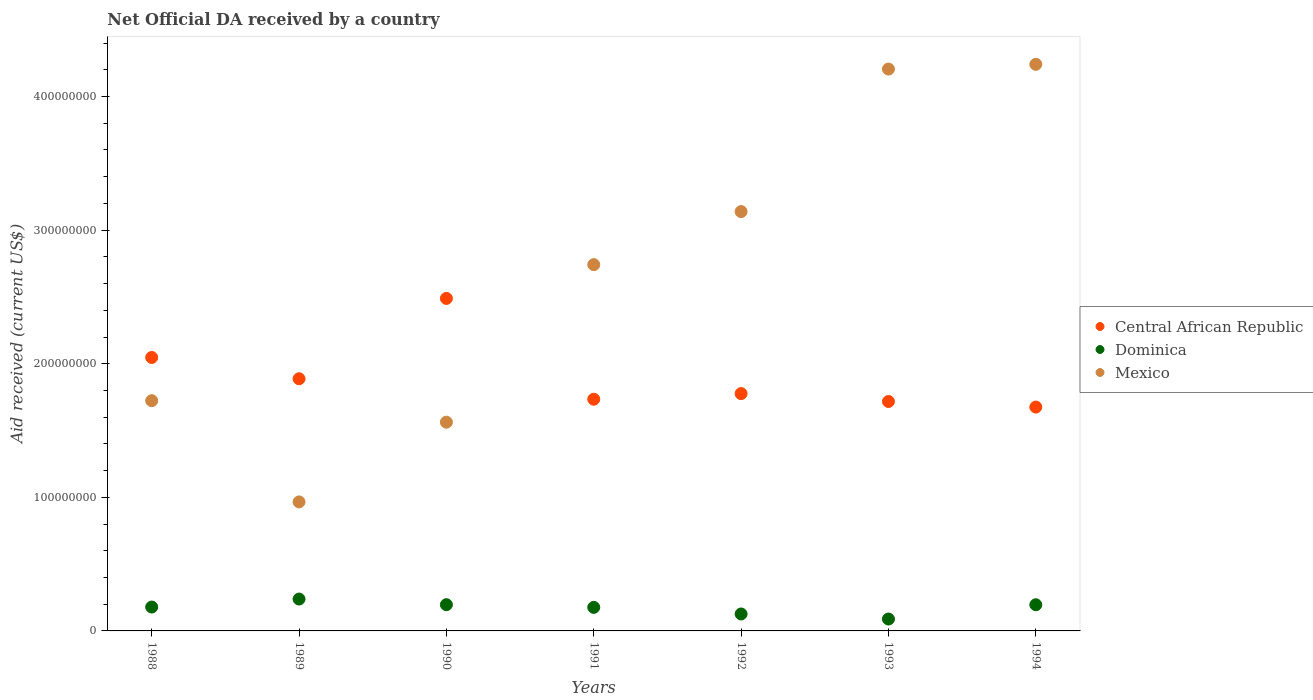What is the net official development assistance aid received in Mexico in 1988?
Ensure brevity in your answer.  1.72e+08. Across all years, what is the maximum net official development assistance aid received in Central African Republic?
Offer a very short reply. 2.49e+08. Across all years, what is the minimum net official development assistance aid received in Dominica?
Keep it short and to the point. 8.91e+06. In which year was the net official development assistance aid received in Mexico minimum?
Your response must be concise. 1989. What is the total net official development assistance aid received in Mexico in the graph?
Offer a terse response. 1.86e+09. What is the difference between the net official development assistance aid received in Central African Republic in 1990 and that in 1991?
Give a very brief answer. 7.54e+07. What is the difference between the net official development assistance aid received in Central African Republic in 1994 and the net official development assistance aid received in Dominica in 1992?
Provide a succinct answer. 1.55e+08. What is the average net official development assistance aid received in Dominica per year?
Give a very brief answer. 1.72e+07. In the year 1993, what is the difference between the net official development assistance aid received in Central African Republic and net official development assistance aid received in Dominica?
Your answer should be compact. 1.63e+08. What is the ratio of the net official development assistance aid received in Central African Republic in 1993 to that in 1994?
Offer a terse response. 1.02. Is the net official development assistance aid received in Central African Republic in 1988 less than that in 1993?
Keep it short and to the point. No. What is the difference between the highest and the second highest net official development assistance aid received in Mexico?
Your response must be concise. 3.56e+06. What is the difference between the highest and the lowest net official development assistance aid received in Mexico?
Offer a terse response. 3.28e+08. In how many years, is the net official development assistance aid received in Central African Republic greater than the average net official development assistance aid received in Central African Republic taken over all years?
Offer a terse response. 2. Is the sum of the net official development assistance aid received in Mexico in 1988 and 1991 greater than the maximum net official development assistance aid received in Central African Republic across all years?
Provide a short and direct response. Yes. Is it the case that in every year, the sum of the net official development assistance aid received in Dominica and net official development assistance aid received in Mexico  is greater than the net official development assistance aid received in Central African Republic?
Your answer should be compact. No. Does the net official development assistance aid received in Dominica monotonically increase over the years?
Your answer should be very brief. No. Is the net official development assistance aid received in Dominica strictly greater than the net official development assistance aid received in Central African Republic over the years?
Keep it short and to the point. No. Is the net official development assistance aid received in Central African Republic strictly less than the net official development assistance aid received in Mexico over the years?
Offer a very short reply. No. How many dotlines are there?
Ensure brevity in your answer.  3. How many years are there in the graph?
Your answer should be very brief. 7. Does the graph contain any zero values?
Offer a very short reply. No. Does the graph contain grids?
Ensure brevity in your answer.  No. Where does the legend appear in the graph?
Provide a short and direct response. Center right. What is the title of the graph?
Offer a terse response. Net Official DA received by a country. What is the label or title of the X-axis?
Offer a very short reply. Years. What is the label or title of the Y-axis?
Provide a short and direct response. Aid received (current US$). What is the Aid received (current US$) of Central African Republic in 1988?
Provide a short and direct response. 2.05e+08. What is the Aid received (current US$) of Dominica in 1988?
Make the answer very short. 1.79e+07. What is the Aid received (current US$) of Mexico in 1988?
Provide a succinct answer. 1.72e+08. What is the Aid received (current US$) in Central African Republic in 1989?
Ensure brevity in your answer.  1.89e+08. What is the Aid received (current US$) of Dominica in 1989?
Ensure brevity in your answer.  2.39e+07. What is the Aid received (current US$) in Mexico in 1989?
Make the answer very short. 9.66e+07. What is the Aid received (current US$) of Central African Republic in 1990?
Provide a short and direct response. 2.49e+08. What is the Aid received (current US$) in Dominica in 1990?
Offer a terse response. 1.96e+07. What is the Aid received (current US$) of Mexico in 1990?
Your answer should be very brief. 1.56e+08. What is the Aid received (current US$) of Central African Republic in 1991?
Your response must be concise. 1.73e+08. What is the Aid received (current US$) in Dominica in 1991?
Provide a short and direct response. 1.76e+07. What is the Aid received (current US$) of Mexico in 1991?
Your response must be concise. 2.74e+08. What is the Aid received (current US$) in Central African Republic in 1992?
Provide a short and direct response. 1.78e+08. What is the Aid received (current US$) in Dominica in 1992?
Offer a terse response. 1.27e+07. What is the Aid received (current US$) of Mexico in 1992?
Ensure brevity in your answer.  3.14e+08. What is the Aid received (current US$) in Central African Republic in 1993?
Your answer should be very brief. 1.72e+08. What is the Aid received (current US$) in Dominica in 1993?
Ensure brevity in your answer.  8.91e+06. What is the Aid received (current US$) in Mexico in 1993?
Provide a short and direct response. 4.21e+08. What is the Aid received (current US$) in Central African Republic in 1994?
Your response must be concise. 1.68e+08. What is the Aid received (current US$) in Dominica in 1994?
Keep it short and to the point. 1.96e+07. What is the Aid received (current US$) of Mexico in 1994?
Make the answer very short. 4.24e+08. Across all years, what is the maximum Aid received (current US$) of Central African Republic?
Make the answer very short. 2.49e+08. Across all years, what is the maximum Aid received (current US$) of Dominica?
Give a very brief answer. 2.39e+07. Across all years, what is the maximum Aid received (current US$) in Mexico?
Offer a very short reply. 4.24e+08. Across all years, what is the minimum Aid received (current US$) in Central African Republic?
Make the answer very short. 1.68e+08. Across all years, what is the minimum Aid received (current US$) in Dominica?
Give a very brief answer. 8.91e+06. Across all years, what is the minimum Aid received (current US$) in Mexico?
Ensure brevity in your answer.  9.66e+07. What is the total Aid received (current US$) of Central African Republic in the graph?
Keep it short and to the point. 1.33e+09. What is the total Aid received (current US$) in Dominica in the graph?
Give a very brief answer. 1.20e+08. What is the total Aid received (current US$) of Mexico in the graph?
Provide a succinct answer. 1.86e+09. What is the difference between the Aid received (current US$) in Central African Republic in 1988 and that in 1989?
Offer a very short reply. 1.59e+07. What is the difference between the Aid received (current US$) in Dominica in 1988 and that in 1989?
Make the answer very short. -5.98e+06. What is the difference between the Aid received (current US$) in Mexico in 1988 and that in 1989?
Your response must be concise. 7.58e+07. What is the difference between the Aid received (current US$) of Central African Republic in 1988 and that in 1990?
Your answer should be compact. -4.42e+07. What is the difference between the Aid received (current US$) of Dominica in 1988 and that in 1990?
Make the answer very short. -1.76e+06. What is the difference between the Aid received (current US$) in Mexico in 1988 and that in 1990?
Keep it short and to the point. 1.61e+07. What is the difference between the Aid received (current US$) of Central African Republic in 1988 and that in 1991?
Ensure brevity in your answer.  3.12e+07. What is the difference between the Aid received (current US$) of Mexico in 1988 and that in 1991?
Offer a terse response. -1.02e+08. What is the difference between the Aid received (current US$) in Central African Republic in 1988 and that in 1992?
Offer a terse response. 2.70e+07. What is the difference between the Aid received (current US$) in Dominica in 1988 and that in 1992?
Provide a succinct answer. 5.18e+06. What is the difference between the Aid received (current US$) in Mexico in 1988 and that in 1992?
Make the answer very short. -1.42e+08. What is the difference between the Aid received (current US$) of Central African Republic in 1988 and that in 1993?
Make the answer very short. 3.30e+07. What is the difference between the Aid received (current US$) of Dominica in 1988 and that in 1993?
Provide a short and direct response. 8.97e+06. What is the difference between the Aid received (current US$) in Mexico in 1988 and that in 1993?
Provide a short and direct response. -2.48e+08. What is the difference between the Aid received (current US$) of Central African Republic in 1988 and that in 1994?
Offer a very short reply. 3.71e+07. What is the difference between the Aid received (current US$) in Dominica in 1988 and that in 1994?
Your response must be concise. -1.71e+06. What is the difference between the Aid received (current US$) in Mexico in 1988 and that in 1994?
Provide a succinct answer. -2.52e+08. What is the difference between the Aid received (current US$) in Central African Republic in 1989 and that in 1990?
Offer a very short reply. -6.01e+07. What is the difference between the Aid received (current US$) in Dominica in 1989 and that in 1990?
Provide a succinct answer. 4.22e+06. What is the difference between the Aid received (current US$) of Mexico in 1989 and that in 1990?
Give a very brief answer. -5.97e+07. What is the difference between the Aid received (current US$) in Central African Republic in 1989 and that in 1991?
Offer a terse response. 1.53e+07. What is the difference between the Aid received (current US$) in Dominica in 1989 and that in 1991?
Your answer should be very brief. 6.23e+06. What is the difference between the Aid received (current US$) of Mexico in 1989 and that in 1991?
Keep it short and to the point. -1.78e+08. What is the difference between the Aid received (current US$) of Central African Republic in 1989 and that in 1992?
Offer a very short reply. 1.11e+07. What is the difference between the Aid received (current US$) of Dominica in 1989 and that in 1992?
Your answer should be very brief. 1.12e+07. What is the difference between the Aid received (current US$) of Mexico in 1989 and that in 1992?
Provide a succinct answer. -2.17e+08. What is the difference between the Aid received (current US$) in Central African Republic in 1989 and that in 1993?
Provide a succinct answer. 1.70e+07. What is the difference between the Aid received (current US$) of Dominica in 1989 and that in 1993?
Offer a very short reply. 1.50e+07. What is the difference between the Aid received (current US$) in Mexico in 1989 and that in 1993?
Your response must be concise. -3.24e+08. What is the difference between the Aid received (current US$) in Central African Republic in 1989 and that in 1994?
Give a very brief answer. 2.12e+07. What is the difference between the Aid received (current US$) in Dominica in 1989 and that in 1994?
Your answer should be compact. 4.27e+06. What is the difference between the Aid received (current US$) of Mexico in 1989 and that in 1994?
Your answer should be compact. -3.28e+08. What is the difference between the Aid received (current US$) of Central African Republic in 1990 and that in 1991?
Offer a very short reply. 7.54e+07. What is the difference between the Aid received (current US$) in Dominica in 1990 and that in 1991?
Offer a terse response. 2.01e+06. What is the difference between the Aid received (current US$) of Mexico in 1990 and that in 1991?
Give a very brief answer. -1.18e+08. What is the difference between the Aid received (current US$) of Central African Republic in 1990 and that in 1992?
Keep it short and to the point. 7.12e+07. What is the difference between the Aid received (current US$) in Dominica in 1990 and that in 1992?
Your answer should be very brief. 6.94e+06. What is the difference between the Aid received (current US$) of Mexico in 1990 and that in 1992?
Make the answer very short. -1.58e+08. What is the difference between the Aid received (current US$) of Central African Republic in 1990 and that in 1993?
Make the answer very short. 7.72e+07. What is the difference between the Aid received (current US$) in Dominica in 1990 and that in 1993?
Ensure brevity in your answer.  1.07e+07. What is the difference between the Aid received (current US$) in Mexico in 1990 and that in 1993?
Your answer should be compact. -2.64e+08. What is the difference between the Aid received (current US$) in Central African Republic in 1990 and that in 1994?
Make the answer very short. 8.13e+07. What is the difference between the Aid received (current US$) in Mexico in 1990 and that in 1994?
Your answer should be very brief. -2.68e+08. What is the difference between the Aid received (current US$) in Central African Republic in 1991 and that in 1992?
Provide a succinct answer. -4.21e+06. What is the difference between the Aid received (current US$) of Dominica in 1991 and that in 1992?
Provide a short and direct response. 4.93e+06. What is the difference between the Aid received (current US$) in Mexico in 1991 and that in 1992?
Your answer should be very brief. -3.97e+07. What is the difference between the Aid received (current US$) in Central African Republic in 1991 and that in 1993?
Your response must be concise. 1.70e+06. What is the difference between the Aid received (current US$) of Dominica in 1991 and that in 1993?
Your response must be concise. 8.72e+06. What is the difference between the Aid received (current US$) of Mexico in 1991 and that in 1993?
Provide a succinct answer. -1.46e+08. What is the difference between the Aid received (current US$) in Central African Republic in 1991 and that in 1994?
Provide a succinct answer. 5.88e+06. What is the difference between the Aid received (current US$) in Dominica in 1991 and that in 1994?
Keep it short and to the point. -1.96e+06. What is the difference between the Aid received (current US$) of Mexico in 1991 and that in 1994?
Give a very brief answer. -1.50e+08. What is the difference between the Aid received (current US$) in Central African Republic in 1992 and that in 1993?
Ensure brevity in your answer.  5.91e+06. What is the difference between the Aid received (current US$) in Dominica in 1992 and that in 1993?
Offer a terse response. 3.79e+06. What is the difference between the Aid received (current US$) in Mexico in 1992 and that in 1993?
Keep it short and to the point. -1.07e+08. What is the difference between the Aid received (current US$) of Central African Republic in 1992 and that in 1994?
Provide a succinct answer. 1.01e+07. What is the difference between the Aid received (current US$) of Dominica in 1992 and that in 1994?
Your answer should be very brief. -6.89e+06. What is the difference between the Aid received (current US$) of Mexico in 1992 and that in 1994?
Your response must be concise. -1.10e+08. What is the difference between the Aid received (current US$) in Central African Republic in 1993 and that in 1994?
Give a very brief answer. 4.18e+06. What is the difference between the Aid received (current US$) of Dominica in 1993 and that in 1994?
Keep it short and to the point. -1.07e+07. What is the difference between the Aid received (current US$) in Mexico in 1993 and that in 1994?
Your answer should be very brief. -3.56e+06. What is the difference between the Aid received (current US$) in Central African Republic in 1988 and the Aid received (current US$) in Dominica in 1989?
Your answer should be very brief. 1.81e+08. What is the difference between the Aid received (current US$) of Central African Republic in 1988 and the Aid received (current US$) of Mexico in 1989?
Offer a terse response. 1.08e+08. What is the difference between the Aid received (current US$) in Dominica in 1988 and the Aid received (current US$) in Mexico in 1989?
Offer a very short reply. -7.87e+07. What is the difference between the Aid received (current US$) in Central African Republic in 1988 and the Aid received (current US$) in Dominica in 1990?
Keep it short and to the point. 1.85e+08. What is the difference between the Aid received (current US$) of Central African Republic in 1988 and the Aid received (current US$) of Mexico in 1990?
Keep it short and to the point. 4.84e+07. What is the difference between the Aid received (current US$) in Dominica in 1988 and the Aid received (current US$) in Mexico in 1990?
Keep it short and to the point. -1.38e+08. What is the difference between the Aid received (current US$) in Central African Republic in 1988 and the Aid received (current US$) in Dominica in 1991?
Provide a succinct answer. 1.87e+08. What is the difference between the Aid received (current US$) in Central African Republic in 1988 and the Aid received (current US$) in Mexico in 1991?
Keep it short and to the point. -6.95e+07. What is the difference between the Aid received (current US$) of Dominica in 1988 and the Aid received (current US$) of Mexico in 1991?
Provide a short and direct response. -2.56e+08. What is the difference between the Aid received (current US$) in Central African Republic in 1988 and the Aid received (current US$) in Dominica in 1992?
Your answer should be very brief. 1.92e+08. What is the difference between the Aid received (current US$) in Central African Republic in 1988 and the Aid received (current US$) in Mexico in 1992?
Provide a short and direct response. -1.09e+08. What is the difference between the Aid received (current US$) in Dominica in 1988 and the Aid received (current US$) in Mexico in 1992?
Provide a succinct answer. -2.96e+08. What is the difference between the Aid received (current US$) in Central African Republic in 1988 and the Aid received (current US$) in Dominica in 1993?
Provide a succinct answer. 1.96e+08. What is the difference between the Aid received (current US$) in Central African Republic in 1988 and the Aid received (current US$) in Mexico in 1993?
Your answer should be compact. -2.16e+08. What is the difference between the Aid received (current US$) in Dominica in 1988 and the Aid received (current US$) in Mexico in 1993?
Keep it short and to the point. -4.03e+08. What is the difference between the Aid received (current US$) of Central African Republic in 1988 and the Aid received (current US$) of Dominica in 1994?
Provide a succinct answer. 1.85e+08. What is the difference between the Aid received (current US$) of Central African Republic in 1988 and the Aid received (current US$) of Mexico in 1994?
Ensure brevity in your answer.  -2.19e+08. What is the difference between the Aid received (current US$) of Dominica in 1988 and the Aid received (current US$) of Mexico in 1994?
Make the answer very short. -4.06e+08. What is the difference between the Aid received (current US$) of Central African Republic in 1989 and the Aid received (current US$) of Dominica in 1990?
Provide a short and direct response. 1.69e+08. What is the difference between the Aid received (current US$) of Central African Republic in 1989 and the Aid received (current US$) of Mexico in 1990?
Your answer should be very brief. 3.25e+07. What is the difference between the Aid received (current US$) of Dominica in 1989 and the Aid received (current US$) of Mexico in 1990?
Your answer should be compact. -1.32e+08. What is the difference between the Aid received (current US$) of Central African Republic in 1989 and the Aid received (current US$) of Dominica in 1991?
Provide a short and direct response. 1.71e+08. What is the difference between the Aid received (current US$) of Central African Republic in 1989 and the Aid received (current US$) of Mexico in 1991?
Offer a terse response. -8.54e+07. What is the difference between the Aid received (current US$) in Dominica in 1989 and the Aid received (current US$) in Mexico in 1991?
Ensure brevity in your answer.  -2.50e+08. What is the difference between the Aid received (current US$) in Central African Republic in 1989 and the Aid received (current US$) in Dominica in 1992?
Your response must be concise. 1.76e+08. What is the difference between the Aid received (current US$) in Central African Republic in 1989 and the Aid received (current US$) in Mexico in 1992?
Ensure brevity in your answer.  -1.25e+08. What is the difference between the Aid received (current US$) in Dominica in 1989 and the Aid received (current US$) in Mexico in 1992?
Make the answer very short. -2.90e+08. What is the difference between the Aid received (current US$) of Central African Republic in 1989 and the Aid received (current US$) of Dominica in 1993?
Provide a short and direct response. 1.80e+08. What is the difference between the Aid received (current US$) of Central African Republic in 1989 and the Aid received (current US$) of Mexico in 1993?
Keep it short and to the point. -2.32e+08. What is the difference between the Aid received (current US$) of Dominica in 1989 and the Aid received (current US$) of Mexico in 1993?
Make the answer very short. -3.97e+08. What is the difference between the Aid received (current US$) in Central African Republic in 1989 and the Aid received (current US$) in Dominica in 1994?
Give a very brief answer. 1.69e+08. What is the difference between the Aid received (current US$) of Central African Republic in 1989 and the Aid received (current US$) of Mexico in 1994?
Ensure brevity in your answer.  -2.35e+08. What is the difference between the Aid received (current US$) of Dominica in 1989 and the Aid received (current US$) of Mexico in 1994?
Offer a terse response. -4.00e+08. What is the difference between the Aid received (current US$) in Central African Republic in 1990 and the Aid received (current US$) in Dominica in 1991?
Keep it short and to the point. 2.31e+08. What is the difference between the Aid received (current US$) of Central African Republic in 1990 and the Aid received (current US$) of Mexico in 1991?
Your answer should be compact. -2.53e+07. What is the difference between the Aid received (current US$) of Dominica in 1990 and the Aid received (current US$) of Mexico in 1991?
Provide a succinct answer. -2.55e+08. What is the difference between the Aid received (current US$) in Central African Republic in 1990 and the Aid received (current US$) in Dominica in 1992?
Your answer should be very brief. 2.36e+08. What is the difference between the Aid received (current US$) of Central African Republic in 1990 and the Aid received (current US$) of Mexico in 1992?
Ensure brevity in your answer.  -6.50e+07. What is the difference between the Aid received (current US$) of Dominica in 1990 and the Aid received (current US$) of Mexico in 1992?
Provide a succinct answer. -2.94e+08. What is the difference between the Aid received (current US$) of Central African Republic in 1990 and the Aid received (current US$) of Dominica in 1993?
Ensure brevity in your answer.  2.40e+08. What is the difference between the Aid received (current US$) in Central African Republic in 1990 and the Aid received (current US$) in Mexico in 1993?
Ensure brevity in your answer.  -1.72e+08. What is the difference between the Aid received (current US$) of Dominica in 1990 and the Aid received (current US$) of Mexico in 1993?
Ensure brevity in your answer.  -4.01e+08. What is the difference between the Aid received (current US$) in Central African Republic in 1990 and the Aid received (current US$) in Dominica in 1994?
Offer a very short reply. 2.29e+08. What is the difference between the Aid received (current US$) of Central African Republic in 1990 and the Aid received (current US$) of Mexico in 1994?
Give a very brief answer. -1.75e+08. What is the difference between the Aid received (current US$) of Dominica in 1990 and the Aid received (current US$) of Mexico in 1994?
Keep it short and to the point. -4.04e+08. What is the difference between the Aid received (current US$) in Central African Republic in 1991 and the Aid received (current US$) in Dominica in 1992?
Your answer should be very brief. 1.61e+08. What is the difference between the Aid received (current US$) of Central African Republic in 1991 and the Aid received (current US$) of Mexico in 1992?
Your answer should be compact. -1.40e+08. What is the difference between the Aid received (current US$) in Dominica in 1991 and the Aid received (current US$) in Mexico in 1992?
Ensure brevity in your answer.  -2.96e+08. What is the difference between the Aid received (current US$) of Central African Republic in 1991 and the Aid received (current US$) of Dominica in 1993?
Offer a very short reply. 1.65e+08. What is the difference between the Aid received (current US$) of Central African Republic in 1991 and the Aid received (current US$) of Mexico in 1993?
Your answer should be compact. -2.47e+08. What is the difference between the Aid received (current US$) in Dominica in 1991 and the Aid received (current US$) in Mexico in 1993?
Make the answer very short. -4.03e+08. What is the difference between the Aid received (current US$) in Central African Republic in 1991 and the Aid received (current US$) in Dominica in 1994?
Provide a succinct answer. 1.54e+08. What is the difference between the Aid received (current US$) of Central African Republic in 1991 and the Aid received (current US$) of Mexico in 1994?
Keep it short and to the point. -2.51e+08. What is the difference between the Aid received (current US$) of Dominica in 1991 and the Aid received (current US$) of Mexico in 1994?
Ensure brevity in your answer.  -4.07e+08. What is the difference between the Aid received (current US$) in Central African Republic in 1992 and the Aid received (current US$) in Dominica in 1993?
Offer a very short reply. 1.69e+08. What is the difference between the Aid received (current US$) in Central African Republic in 1992 and the Aid received (current US$) in Mexico in 1993?
Provide a succinct answer. -2.43e+08. What is the difference between the Aid received (current US$) in Dominica in 1992 and the Aid received (current US$) in Mexico in 1993?
Ensure brevity in your answer.  -4.08e+08. What is the difference between the Aid received (current US$) in Central African Republic in 1992 and the Aid received (current US$) in Dominica in 1994?
Your response must be concise. 1.58e+08. What is the difference between the Aid received (current US$) in Central African Republic in 1992 and the Aid received (current US$) in Mexico in 1994?
Keep it short and to the point. -2.46e+08. What is the difference between the Aid received (current US$) of Dominica in 1992 and the Aid received (current US$) of Mexico in 1994?
Offer a terse response. -4.11e+08. What is the difference between the Aid received (current US$) of Central African Republic in 1993 and the Aid received (current US$) of Dominica in 1994?
Offer a very short reply. 1.52e+08. What is the difference between the Aid received (current US$) in Central African Republic in 1993 and the Aid received (current US$) in Mexico in 1994?
Your answer should be very brief. -2.52e+08. What is the difference between the Aid received (current US$) in Dominica in 1993 and the Aid received (current US$) in Mexico in 1994?
Your response must be concise. -4.15e+08. What is the average Aid received (current US$) in Central African Republic per year?
Offer a terse response. 1.90e+08. What is the average Aid received (current US$) of Dominica per year?
Your answer should be very brief. 1.72e+07. What is the average Aid received (current US$) in Mexico per year?
Your answer should be very brief. 2.65e+08. In the year 1988, what is the difference between the Aid received (current US$) in Central African Republic and Aid received (current US$) in Dominica?
Provide a short and direct response. 1.87e+08. In the year 1988, what is the difference between the Aid received (current US$) in Central African Republic and Aid received (current US$) in Mexico?
Offer a terse response. 3.23e+07. In the year 1988, what is the difference between the Aid received (current US$) of Dominica and Aid received (current US$) of Mexico?
Offer a terse response. -1.54e+08. In the year 1989, what is the difference between the Aid received (current US$) of Central African Republic and Aid received (current US$) of Dominica?
Keep it short and to the point. 1.65e+08. In the year 1989, what is the difference between the Aid received (current US$) of Central African Republic and Aid received (current US$) of Mexico?
Ensure brevity in your answer.  9.22e+07. In the year 1989, what is the difference between the Aid received (current US$) of Dominica and Aid received (current US$) of Mexico?
Make the answer very short. -7.27e+07. In the year 1990, what is the difference between the Aid received (current US$) in Central African Republic and Aid received (current US$) in Dominica?
Provide a short and direct response. 2.29e+08. In the year 1990, what is the difference between the Aid received (current US$) in Central African Republic and Aid received (current US$) in Mexico?
Offer a very short reply. 9.26e+07. In the year 1990, what is the difference between the Aid received (current US$) of Dominica and Aid received (current US$) of Mexico?
Offer a very short reply. -1.37e+08. In the year 1991, what is the difference between the Aid received (current US$) of Central African Republic and Aid received (current US$) of Dominica?
Provide a short and direct response. 1.56e+08. In the year 1991, what is the difference between the Aid received (current US$) of Central African Republic and Aid received (current US$) of Mexico?
Give a very brief answer. -1.01e+08. In the year 1991, what is the difference between the Aid received (current US$) in Dominica and Aid received (current US$) in Mexico?
Your response must be concise. -2.57e+08. In the year 1992, what is the difference between the Aid received (current US$) in Central African Republic and Aid received (current US$) in Dominica?
Ensure brevity in your answer.  1.65e+08. In the year 1992, what is the difference between the Aid received (current US$) in Central African Republic and Aid received (current US$) in Mexico?
Give a very brief answer. -1.36e+08. In the year 1992, what is the difference between the Aid received (current US$) in Dominica and Aid received (current US$) in Mexico?
Ensure brevity in your answer.  -3.01e+08. In the year 1993, what is the difference between the Aid received (current US$) in Central African Republic and Aid received (current US$) in Dominica?
Provide a succinct answer. 1.63e+08. In the year 1993, what is the difference between the Aid received (current US$) in Central African Republic and Aid received (current US$) in Mexico?
Ensure brevity in your answer.  -2.49e+08. In the year 1993, what is the difference between the Aid received (current US$) in Dominica and Aid received (current US$) in Mexico?
Offer a terse response. -4.12e+08. In the year 1994, what is the difference between the Aid received (current US$) in Central African Republic and Aid received (current US$) in Dominica?
Offer a terse response. 1.48e+08. In the year 1994, what is the difference between the Aid received (current US$) in Central African Republic and Aid received (current US$) in Mexico?
Keep it short and to the point. -2.57e+08. In the year 1994, what is the difference between the Aid received (current US$) of Dominica and Aid received (current US$) of Mexico?
Provide a succinct answer. -4.05e+08. What is the ratio of the Aid received (current US$) in Central African Republic in 1988 to that in 1989?
Your answer should be very brief. 1.08. What is the ratio of the Aid received (current US$) of Dominica in 1988 to that in 1989?
Your answer should be compact. 0.75. What is the ratio of the Aid received (current US$) of Mexico in 1988 to that in 1989?
Your response must be concise. 1.78. What is the ratio of the Aid received (current US$) in Central African Republic in 1988 to that in 1990?
Provide a succinct answer. 0.82. What is the ratio of the Aid received (current US$) in Dominica in 1988 to that in 1990?
Your response must be concise. 0.91. What is the ratio of the Aid received (current US$) in Mexico in 1988 to that in 1990?
Your answer should be very brief. 1.1. What is the ratio of the Aid received (current US$) of Central African Republic in 1988 to that in 1991?
Your response must be concise. 1.18. What is the ratio of the Aid received (current US$) of Dominica in 1988 to that in 1991?
Provide a succinct answer. 1.01. What is the ratio of the Aid received (current US$) of Mexico in 1988 to that in 1991?
Give a very brief answer. 0.63. What is the ratio of the Aid received (current US$) of Central African Republic in 1988 to that in 1992?
Offer a terse response. 1.15. What is the ratio of the Aid received (current US$) of Dominica in 1988 to that in 1992?
Keep it short and to the point. 1.41. What is the ratio of the Aid received (current US$) in Mexico in 1988 to that in 1992?
Make the answer very short. 0.55. What is the ratio of the Aid received (current US$) in Central African Republic in 1988 to that in 1993?
Offer a very short reply. 1.19. What is the ratio of the Aid received (current US$) of Dominica in 1988 to that in 1993?
Keep it short and to the point. 2.01. What is the ratio of the Aid received (current US$) in Mexico in 1988 to that in 1993?
Offer a terse response. 0.41. What is the ratio of the Aid received (current US$) of Central African Republic in 1988 to that in 1994?
Provide a succinct answer. 1.22. What is the ratio of the Aid received (current US$) of Dominica in 1988 to that in 1994?
Offer a very short reply. 0.91. What is the ratio of the Aid received (current US$) of Mexico in 1988 to that in 1994?
Offer a terse response. 0.41. What is the ratio of the Aid received (current US$) in Central African Republic in 1989 to that in 1990?
Give a very brief answer. 0.76. What is the ratio of the Aid received (current US$) of Dominica in 1989 to that in 1990?
Ensure brevity in your answer.  1.21. What is the ratio of the Aid received (current US$) of Mexico in 1989 to that in 1990?
Keep it short and to the point. 0.62. What is the ratio of the Aid received (current US$) in Central African Republic in 1989 to that in 1991?
Provide a short and direct response. 1.09. What is the ratio of the Aid received (current US$) in Dominica in 1989 to that in 1991?
Provide a short and direct response. 1.35. What is the ratio of the Aid received (current US$) of Mexico in 1989 to that in 1991?
Offer a terse response. 0.35. What is the ratio of the Aid received (current US$) in Central African Republic in 1989 to that in 1992?
Your response must be concise. 1.06. What is the ratio of the Aid received (current US$) of Dominica in 1989 to that in 1992?
Your answer should be compact. 1.88. What is the ratio of the Aid received (current US$) of Mexico in 1989 to that in 1992?
Keep it short and to the point. 0.31. What is the ratio of the Aid received (current US$) in Central African Republic in 1989 to that in 1993?
Your answer should be compact. 1.1. What is the ratio of the Aid received (current US$) of Dominica in 1989 to that in 1993?
Your answer should be very brief. 2.68. What is the ratio of the Aid received (current US$) in Mexico in 1989 to that in 1993?
Keep it short and to the point. 0.23. What is the ratio of the Aid received (current US$) of Central African Republic in 1989 to that in 1994?
Provide a short and direct response. 1.13. What is the ratio of the Aid received (current US$) of Dominica in 1989 to that in 1994?
Your response must be concise. 1.22. What is the ratio of the Aid received (current US$) in Mexico in 1989 to that in 1994?
Give a very brief answer. 0.23. What is the ratio of the Aid received (current US$) in Central African Republic in 1990 to that in 1991?
Make the answer very short. 1.44. What is the ratio of the Aid received (current US$) in Dominica in 1990 to that in 1991?
Give a very brief answer. 1.11. What is the ratio of the Aid received (current US$) of Mexico in 1990 to that in 1991?
Your answer should be compact. 0.57. What is the ratio of the Aid received (current US$) in Central African Republic in 1990 to that in 1992?
Your answer should be very brief. 1.4. What is the ratio of the Aid received (current US$) in Dominica in 1990 to that in 1992?
Offer a terse response. 1.55. What is the ratio of the Aid received (current US$) in Mexico in 1990 to that in 1992?
Ensure brevity in your answer.  0.5. What is the ratio of the Aid received (current US$) in Central African Republic in 1990 to that in 1993?
Offer a very short reply. 1.45. What is the ratio of the Aid received (current US$) in Dominica in 1990 to that in 1993?
Your answer should be very brief. 2.2. What is the ratio of the Aid received (current US$) in Mexico in 1990 to that in 1993?
Provide a succinct answer. 0.37. What is the ratio of the Aid received (current US$) of Central African Republic in 1990 to that in 1994?
Keep it short and to the point. 1.49. What is the ratio of the Aid received (current US$) in Dominica in 1990 to that in 1994?
Your answer should be very brief. 1. What is the ratio of the Aid received (current US$) of Mexico in 1990 to that in 1994?
Provide a succinct answer. 0.37. What is the ratio of the Aid received (current US$) of Central African Republic in 1991 to that in 1992?
Provide a short and direct response. 0.98. What is the ratio of the Aid received (current US$) in Dominica in 1991 to that in 1992?
Offer a terse response. 1.39. What is the ratio of the Aid received (current US$) of Mexico in 1991 to that in 1992?
Give a very brief answer. 0.87. What is the ratio of the Aid received (current US$) in Central African Republic in 1991 to that in 1993?
Your answer should be compact. 1.01. What is the ratio of the Aid received (current US$) in Dominica in 1991 to that in 1993?
Make the answer very short. 1.98. What is the ratio of the Aid received (current US$) of Mexico in 1991 to that in 1993?
Ensure brevity in your answer.  0.65. What is the ratio of the Aid received (current US$) in Central African Republic in 1991 to that in 1994?
Your answer should be very brief. 1.04. What is the ratio of the Aid received (current US$) in Dominica in 1991 to that in 1994?
Your response must be concise. 0.9. What is the ratio of the Aid received (current US$) of Mexico in 1991 to that in 1994?
Keep it short and to the point. 0.65. What is the ratio of the Aid received (current US$) in Central African Republic in 1992 to that in 1993?
Your response must be concise. 1.03. What is the ratio of the Aid received (current US$) of Dominica in 1992 to that in 1993?
Keep it short and to the point. 1.43. What is the ratio of the Aid received (current US$) of Mexico in 1992 to that in 1993?
Your response must be concise. 0.75. What is the ratio of the Aid received (current US$) of Central African Republic in 1992 to that in 1994?
Give a very brief answer. 1.06. What is the ratio of the Aid received (current US$) of Dominica in 1992 to that in 1994?
Provide a short and direct response. 0.65. What is the ratio of the Aid received (current US$) in Mexico in 1992 to that in 1994?
Ensure brevity in your answer.  0.74. What is the ratio of the Aid received (current US$) in Central African Republic in 1993 to that in 1994?
Give a very brief answer. 1.02. What is the ratio of the Aid received (current US$) in Dominica in 1993 to that in 1994?
Your answer should be very brief. 0.45. What is the ratio of the Aid received (current US$) of Mexico in 1993 to that in 1994?
Keep it short and to the point. 0.99. What is the difference between the highest and the second highest Aid received (current US$) of Central African Republic?
Offer a very short reply. 4.42e+07. What is the difference between the highest and the second highest Aid received (current US$) in Dominica?
Your answer should be compact. 4.22e+06. What is the difference between the highest and the second highest Aid received (current US$) of Mexico?
Give a very brief answer. 3.56e+06. What is the difference between the highest and the lowest Aid received (current US$) in Central African Republic?
Keep it short and to the point. 8.13e+07. What is the difference between the highest and the lowest Aid received (current US$) of Dominica?
Provide a succinct answer. 1.50e+07. What is the difference between the highest and the lowest Aid received (current US$) in Mexico?
Provide a short and direct response. 3.28e+08. 